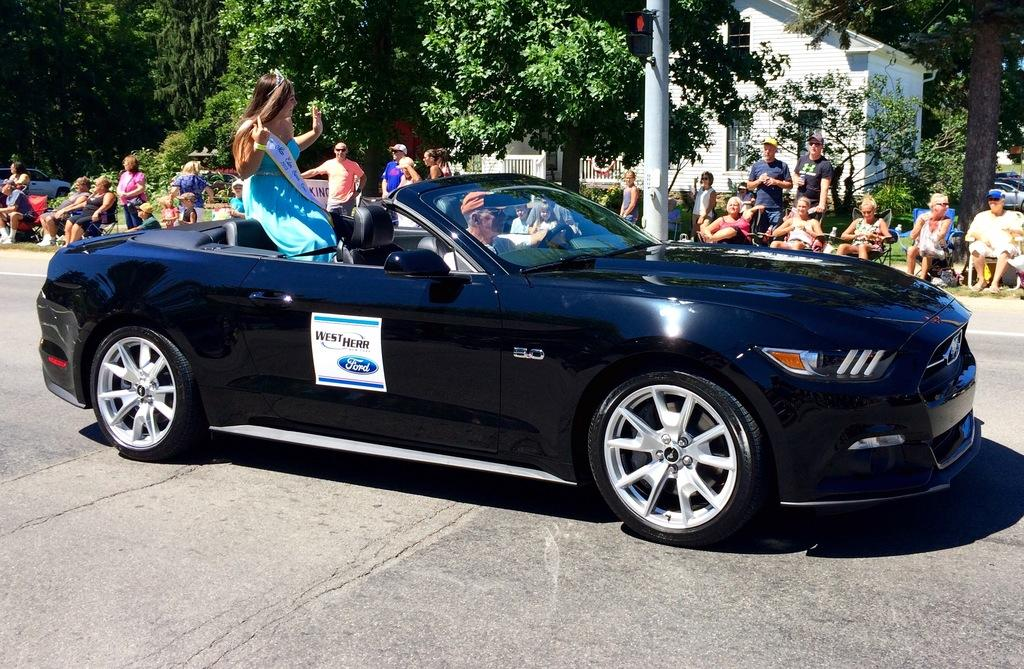How many people are in the car in the image? There are two people in a car in the image. Where is the car located? The car is on the road in the image. What can be seen behind the car? There are people, trees, buildings, and vehicles visible behind the car in the image. What type of chain can be seen connecting the rabbits in the image? There are no rabbits or chains present in the image. How does the acoustics of the car affect the conversation between the two people in the image? The provided facts do not mention anything about the acoustics of the car, so it cannot be determined how it affects the conversation between the two people. 